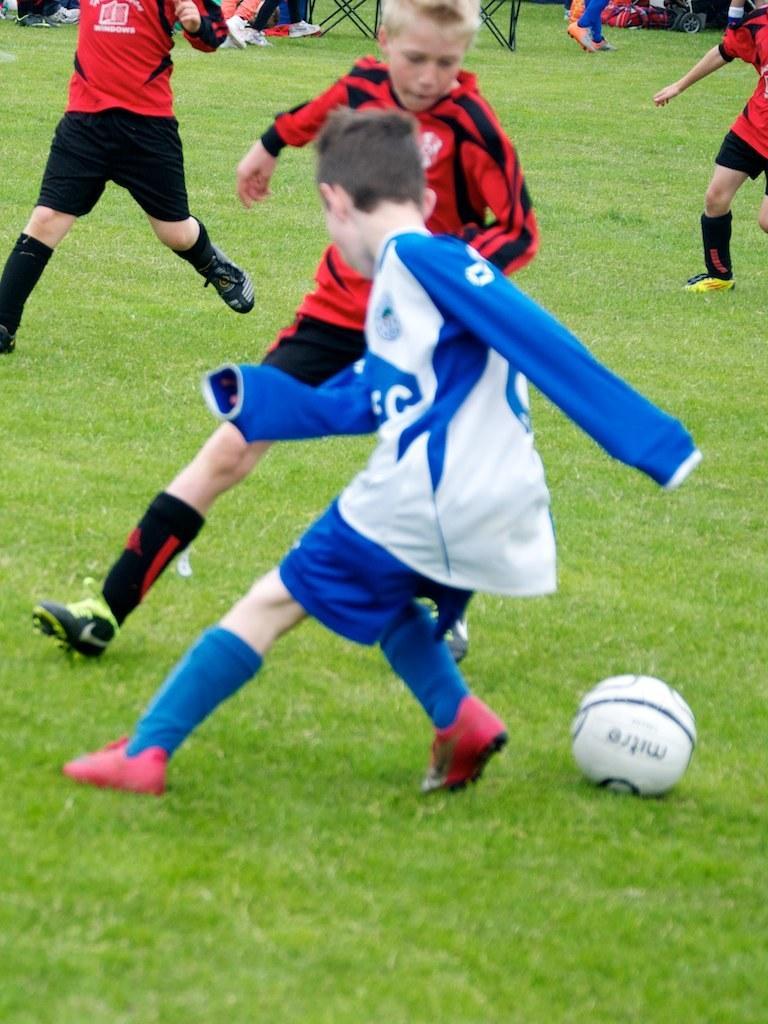Could you give a brief overview of what you see in this image? In this image I can see an open grass ground and on it I can see few children are standing. I can also see all of them are wearing sports jerseys and football shoes. On the right side of this image I can see a white colour football and in the background I can see a bag and few black colour things. 